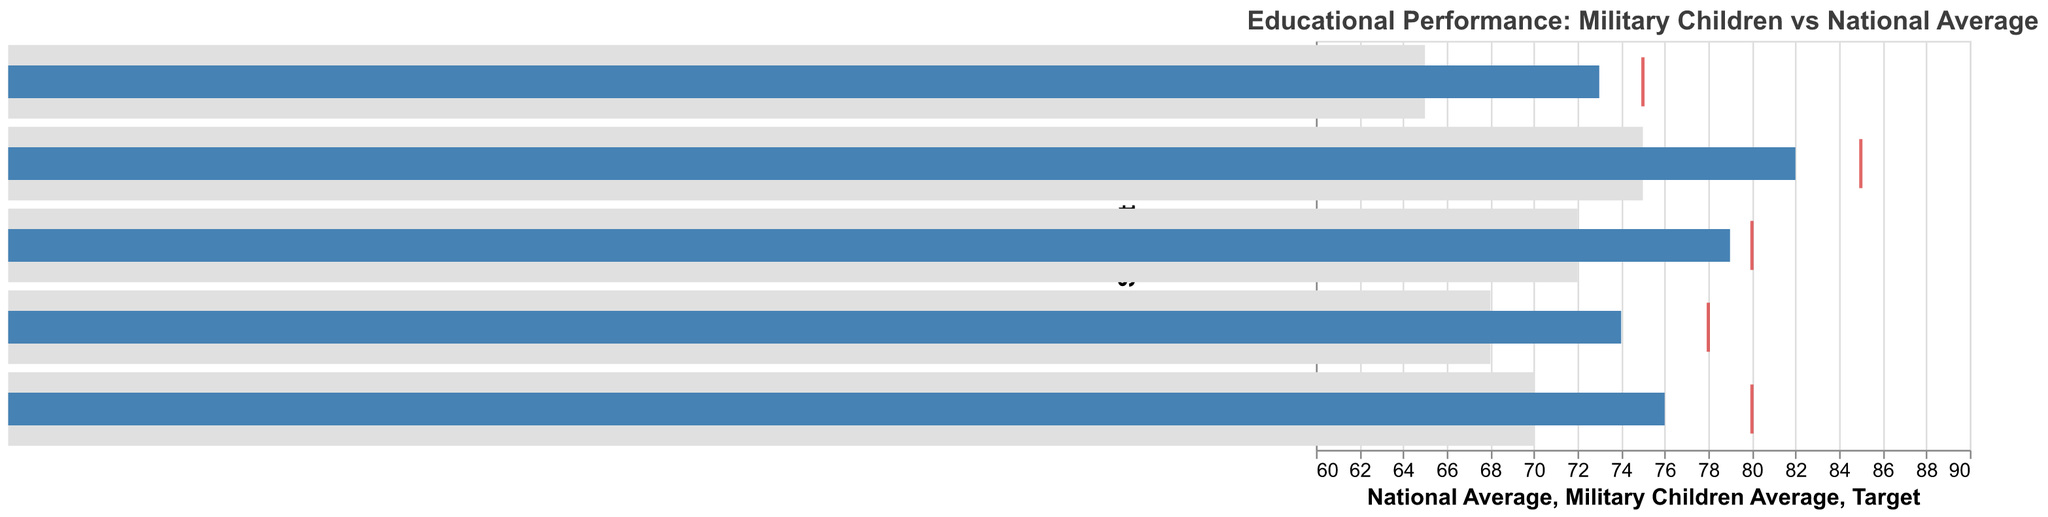Which subject has the highest National Average? The National Average across different subjects is shown as the lighter-colored bars in the Bullet Chart. We can compare these values to see that the highest National Average is for Math with a value of 75.
Answer: Math What's the difference between the Military Children Average and the Target in Science? The Military Children Average for Science is 74, and the Target is 78. The difference between them is calculated as 78 - 74 = 4.
Answer: 4 How many subjects have a Target higher than 75? To determine which subjects have a Target higher than 75, we look at the Target values for all subjects. Math (85), Reading (80), Science (78), and Social Studies (80) all have Targets above 75. There are 4 such subjects.
Answer: 4 Which subject shows the smallest disparity between the National Average and the Military Children Average? The disparity between the National Average and the Military Children Average for each subject can be found by subtracting the National Average from the Military Children Average. Math: 82-75=7, Reading: 79-72=7, Science: 74-68=6, Social Studies: 76-70=6, Foreign Language: 73-65=8. The smallest disparity is in Science and Social Studies, both with a value of 6.
Answer: Science and Social Studies In which subject do Military Children perform better compared to the National Average by the largest margin? By comparing the differences between the Military Children Average and the National Average for each subject, we find: Math: 82-75=7, Reading: 79-72=7, Science: 74-68=6, Social Studies: 76-70=6, Foreign Language: 73-65=8. The largest margin is in Foreign Language with a difference of 8.
Answer: Foreign Language What is the average Target value across all subjects? The Target values across all subjects are Math (85), Reading (80), Science (78), Social Studies (80), and Foreign Language (75). Adding these values together (85+80+78+80+75=398) and dividing by the number of subjects (5) gives an average of 398/5 = 79.6.
Answer: 79.6 Which subjects have Military Children met or exceeded their Target? We compare the Military Children Average with the Target for each subject. Math: 82 < 85, Reading: 79 < 80, Science: 74 < 78, Social Studies: 76 < 80, Foreign Language: 73 < 75. Military Children have not met or exceeded the Target in any subject.
Answer: None How much higher is the Military Children Average in Math compared to the National Average? The Military Children Average in Math is 82, and the National Average is 75. The difference is 82 - 75 = 7.
Answer: 7 